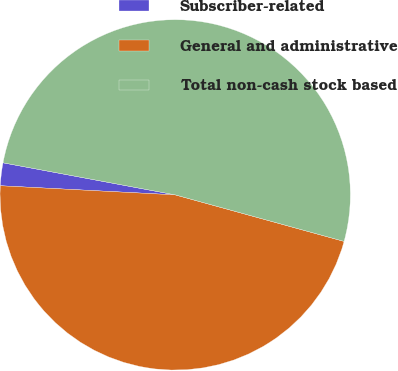Convert chart. <chart><loc_0><loc_0><loc_500><loc_500><pie_chart><fcel>Subscriber-related<fcel>General and administrative<fcel>Total non-cash stock based<nl><fcel>2.1%<fcel>46.55%<fcel>51.35%<nl></chart> 